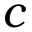<formula> <loc_0><loc_0><loc_500><loc_500>c</formula> 